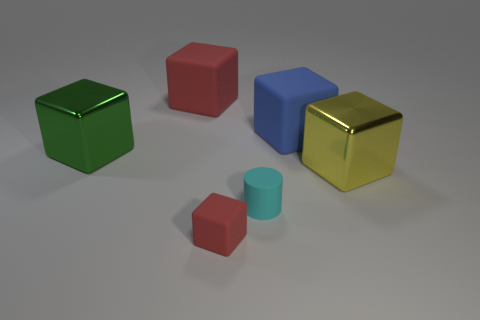What shape is the object that is the same color as the tiny cube?
Give a very brief answer. Cube. There is a big matte thing that is on the left side of the cyan object; is its color the same as the tiny block?
Make the answer very short. Yes. Are any large yellow objects visible?
Your response must be concise. Yes. What number of other things are there of the same shape as the blue rubber thing?
Offer a very short reply. 4. There is a rubber block in front of the big yellow metallic block; is its color the same as the big rubber object to the left of the small cylinder?
Ensure brevity in your answer.  Yes. What is the size of the red matte object behind the metallic object that is to the left of the large matte object on the left side of the small red block?
Offer a very short reply. Large. There is a rubber object that is to the right of the tiny matte block and to the left of the blue thing; what shape is it?
Your answer should be compact. Cylinder. Are there an equal number of big yellow metallic objects that are to the left of the green object and small cyan things on the right side of the large blue block?
Your answer should be compact. Yes. Is there a tiny purple cylinder made of the same material as the large yellow block?
Your answer should be very brief. No. Is the red cube left of the small red block made of the same material as the large green object?
Make the answer very short. No. 